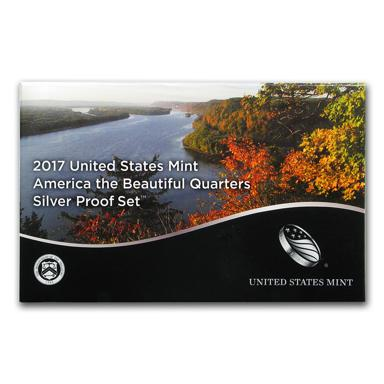What is the name of the silver proof set mentioned in the image? The name of the silver proof set is "2017 United States Mint America the Beautiful Quarters Silver Proof Set." Who issued the silver proof set? The United States Mint issued the silver proof set. 